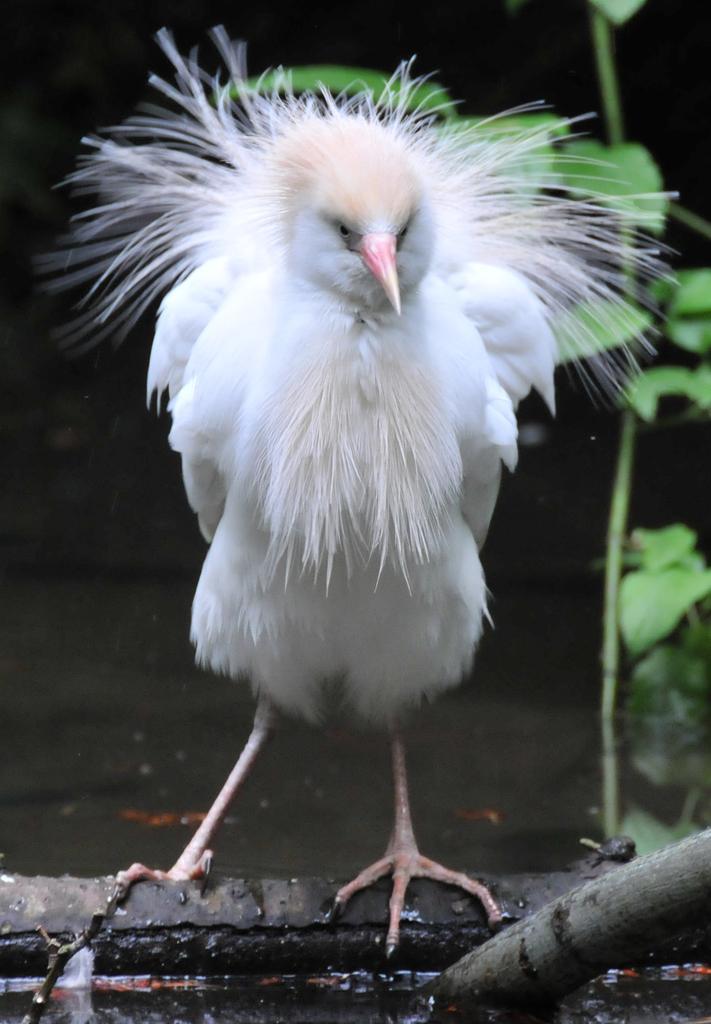How would you summarize this image in a sentence or two? In this picture I can see a bird standing, there is water, and in the background there is a branch with leaves. 